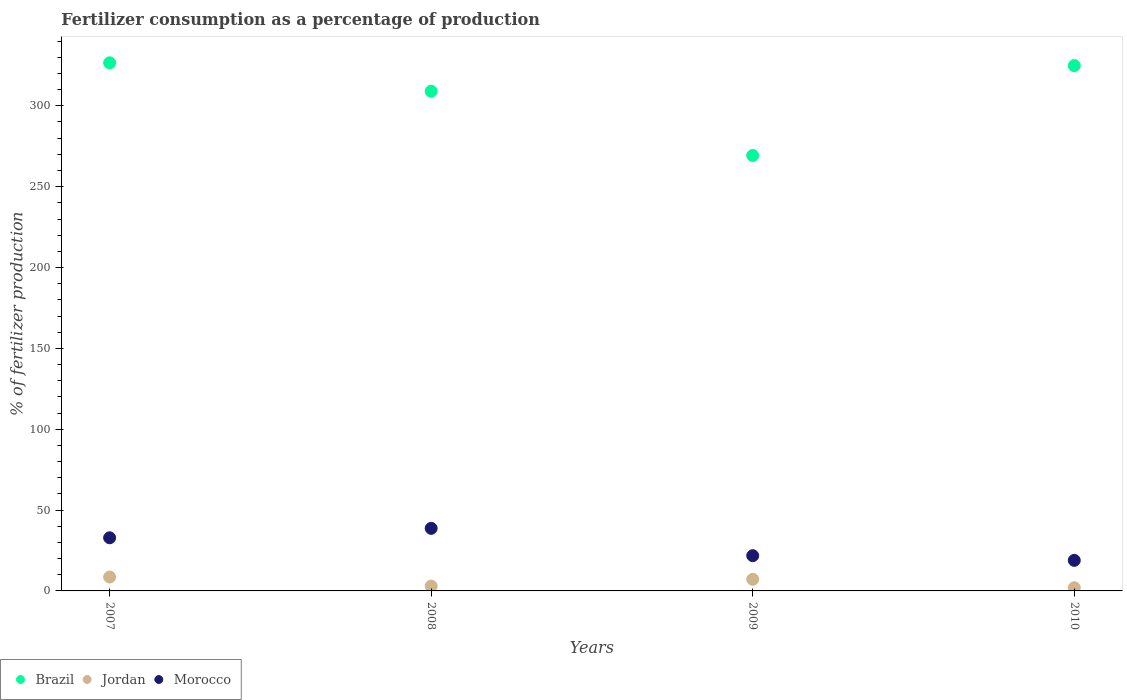What is the percentage of fertilizers consumed in Jordan in 2009?
Offer a very short reply. 7.18. Across all years, what is the maximum percentage of fertilizers consumed in Jordan?
Offer a very short reply. 8.6. Across all years, what is the minimum percentage of fertilizers consumed in Jordan?
Offer a very short reply. 1.96. In which year was the percentage of fertilizers consumed in Morocco maximum?
Your answer should be very brief. 2008. What is the total percentage of fertilizers consumed in Morocco in the graph?
Your response must be concise. 112.24. What is the difference between the percentage of fertilizers consumed in Brazil in 2007 and that in 2010?
Your answer should be very brief. 1.72. What is the difference between the percentage of fertilizers consumed in Brazil in 2007 and the percentage of fertilizers consumed in Morocco in 2009?
Keep it short and to the point. 304.79. What is the average percentage of fertilizers consumed in Brazil per year?
Provide a short and direct response. 307.43. In the year 2009, what is the difference between the percentage of fertilizers consumed in Brazil and percentage of fertilizers consumed in Jordan?
Ensure brevity in your answer.  262.09. In how many years, is the percentage of fertilizers consumed in Jordan greater than 310 %?
Give a very brief answer. 0. What is the ratio of the percentage of fertilizers consumed in Morocco in 2007 to that in 2009?
Give a very brief answer. 1.51. Is the percentage of fertilizers consumed in Morocco in 2007 less than that in 2009?
Keep it short and to the point. No. Is the difference between the percentage of fertilizers consumed in Brazil in 2007 and 2008 greater than the difference between the percentage of fertilizers consumed in Jordan in 2007 and 2008?
Your answer should be compact. Yes. What is the difference between the highest and the second highest percentage of fertilizers consumed in Brazil?
Give a very brief answer. 1.72. What is the difference between the highest and the lowest percentage of fertilizers consumed in Brazil?
Offer a terse response. 57.32. In how many years, is the percentage of fertilizers consumed in Brazil greater than the average percentage of fertilizers consumed in Brazil taken over all years?
Offer a very short reply. 3. Is the sum of the percentage of fertilizers consumed in Jordan in 2008 and 2010 greater than the maximum percentage of fertilizers consumed in Morocco across all years?
Offer a very short reply. No. Is it the case that in every year, the sum of the percentage of fertilizers consumed in Morocco and percentage of fertilizers consumed in Jordan  is greater than the percentage of fertilizers consumed in Brazil?
Make the answer very short. No. Does the percentage of fertilizers consumed in Morocco monotonically increase over the years?
Give a very brief answer. No. Is the percentage of fertilizers consumed in Morocco strictly greater than the percentage of fertilizers consumed in Brazil over the years?
Keep it short and to the point. No. Is the percentage of fertilizers consumed in Brazil strictly less than the percentage of fertilizers consumed in Jordan over the years?
Give a very brief answer. No. Does the graph contain any zero values?
Your answer should be very brief. No. Where does the legend appear in the graph?
Give a very brief answer. Bottom left. How are the legend labels stacked?
Your answer should be very brief. Horizontal. What is the title of the graph?
Make the answer very short. Fertilizer consumption as a percentage of production. Does "Mauritania" appear as one of the legend labels in the graph?
Provide a succinct answer. No. What is the label or title of the X-axis?
Keep it short and to the point. Years. What is the label or title of the Y-axis?
Give a very brief answer. % of fertilizer production. What is the % of fertilizer production in Brazil in 2007?
Ensure brevity in your answer.  326.59. What is the % of fertilizer production in Jordan in 2007?
Provide a short and direct response. 8.6. What is the % of fertilizer production in Morocco in 2007?
Offer a terse response. 32.86. What is the % of fertilizer production in Brazil in 2008?
Make the answer very short. 309.01. What is the % of fertilizer production of Jordan in 2008?
Your response must be concise. 2.99. What is the % of fertilizer production of Morocco in 2008?
Your answer should be compact. 38.69. What is the % of fertilizer production in Brazil in 2009?
Make the answer very short. 269.27. What is the % of fertilizer production of Jordan in 2009?
Your response must be concise. 7.18. What is the % of fertilizer production in Morocco in 2009?
Give a very brief answer. 21.79. What is the % of fertilizer production in Brazil in 2010?
Provide a short and direct response. 324.87. What is the % of fertilizer production in Jordan in 2010?
Make the answer very short. 1.96. What is the % of fertilizer production of Morocco in 2010?
Offer a terse response. 18.9. Across all years, what is the maximum % of fertilizer production of Brazil?
Keep it short and to the point. 326.59. Across all years, what is the maximum % of fertilizer production of Jordan?
Offer a terse response. 8.6. Across all years, what is the maximum % of fertilizer production of Morocco?
Your answer should be compact. 38.69. Across all years, what is the minimum % of fertilizer production in Brazil?
Provide a short and direct response. 269.27. Across all years, what is the minimum % of fertilizer production of Jordan?
Provide a succinct answer. 1.96. Across all years, what is the minimum % of fertilizer production of Morocco?
Provide a short and direct response. 18.9. What is the total % of fertilizer production in Brazil in the graph?
Ensure brevity in your answer.  1229.73. What is the total % of fertilizer production of Jordan in the graph?
Provide a short and direct response. 20.73. What is the total % of fertilizer production in Morocco in the graph?
Provide a short and direct response. 112.24. What is the difference between the % of fertilizer production in Brazil in 2007 and that in 2008?
Offer a very short reply. 17.58. What is the difference between the % of fertilizer production of Jordan in 2007 and that in 2008?
Offer a terse response. 5.61. What is the difference between the % of fertilizer production in Morocco in 2007 and that in 2008?
Your response must be concise. -5.83. What is the difference between the % of fertilizer production of Brazil in 2007 and that in 2009?
Your answer should be compact. 57.32. What is the difference between the % of fertilizer production of Jordan in 2007 and that in 2009?
Make the answer very short. 1.42. What is the difference between the % of fertilizer production of Morocco in 2007 and that in 2009?
Your answer should be compact. 11.07. What is the difference between the % of fertilizer production in Brazil in 2007 and that in 2010?
Your answer should be compact. 1.72. What is the difference between the % of fertilizer production of Jordan in 2007 and that in 2010?
Keep it short and to the point. 6.65. What is the difference between the % of fertilizer production in Morocco in 2007 and that in 2010?
Keep it short and to the point. 13.96. What is the difference between the % of fertilizer production in Brazil in 2008 and that in 2009?
Keep it short and to the point. 39.74. What is the difference between the % of fertilizer production of Jordan in 2008 and that in 2009?
Offer a very short reply. -4.19. What is the difference between the % of fertilizer production of Morocco in 2008 and that in 2009?
Give a very brief answer. 16.9. What is the difference between the % of fertilizer production in Brazil in 2008 and that in 2010?
Make the answer very short. -15.86. What is the difference between the % of fertilizer production in Jordan in 2008 and that in 2010?
Provide a succinct answer. 1.04. What is the difference between the % of fertilizer production in Morocco in 2008 and that in 2010?
Provide a short and direct response. 19.8. What is the difference between the % of fertilizer production of Brazil in 2009 and that in 2010?
Offer a very short reply. -55.6. What is the difference between the % of fertilizer production of Jordan in 2009 and that in 2010?
Make the answer very short. 5.22. What is the difference between the % of fertilizer production in Morocco in 2009 and that in 2010?
Keep it short and to the point. 2.9. What is the difference between the % of fertilizer production of Brazil in 2007 and the % of fertilizer production of Jordan in 2008?
Provide a succinct answer. 323.59. What is the difference between the % of fertilizer production in Brazil in 2007 and the % of fertilizer production in Morocco in 2008?
Offer a terse response. 287.89. What is the difference between the % of fertilizer production of Jordan in 2007 and the % of fertilizer production of Morocco in 2008?
Provide a short and direct response. -30.09. What is the difference between the % of fertilizer production in Brazil in 2007 and the % of fertilizer production in Jordan in 2009?
Ensure brevity in your answer.  319.41. What is the difference between the % of fertilizer production in Brazil in 2007 and the % of fertilizer production in Morocco in 2009?
Offer a very short reply. 304.79. What is the difference between the % of fertilizer production in Jordan in 2007 and the % of fertilizer production in Morocco in 2009?
Offer a terse response. -13.19. What is the difference between the % of fertilizer production in Brazil in 2007 and the % of fertilizer production in Jordan in 2010?
Provide a succinct answer. 324.63. What is the difference between the % of fertilizer production of Brazil in 2007 and the % of fertilizer production of Morocco in 2010?
Your answer should be compact. 307.69. What is the difference between the % of fertilizer production in Jordan in 2007 and the % of fertilizer production in Morocco in 2010?
Your response must be concise. -10.29. What is the difference between the % of fertilizer production of Brazil in 2008 and the % of fertilizer production of Jordan in 2009?
Your response must be concise. 301.83. What is the difference between the % of fertilizer production in Brazil in 2008 and the % of fertilizer production in Morocco in 2009?
Offer a very short reply. 287.22. What is the difference between the % of fertilizer production of Jordan in 2008 and the % of fertilizer production of Morocco in 2009?
Offer a terse response. -18.8. What is the difference between the % of fertilizer production in Brazil in 2008 and the % of fertilizer production in Jordan in 2010?
Your response must be concise. 307.05. What is the difference between the % of fertilizer production in Brazil in 2008 and the % of fertilizer production in Morocco in 2010?
Your answer should be very brief. 290.11. What is the difference between the % of fertilizer production in Jordan in 2008 and the % of fertilizer production in Morocco in 2010?
Make the answer very short. -15.9. What is the difference between the % of fertilizer production of Brazil in 2009 and the % of fertilizer production of Jordan in 2010?
Your response must be concise. 267.31. What is the difference between the % of fertilizer production in Brazil in 2009 and the % of fertilizer production in Morocco in 2010?
Offer a terse response. 250.37. What is the difference between the % of fertilizer production in Jordan in 2009 and the % of fertilizer production in Morocco in 2010?
Provide a succinct answer. -11.72. What is the average % of fertilizer production in Brazil per year?
Offer a terse response. 307.43. What is the average % of fertilizer production in Jordan per year?
Provide a short and direct response. 5.18. What is the average % of fertilizer production of Morocco per year?
Make the answer very short. 28.06. In the year 2007, what is the difference between the % of fertilizer production in Brazil and % of fertilizer production in Jordan?
Your answer should be compact. 317.98. In the year 2007, what is the difference between the % of fertilizer production in Brazil and % of fertilizer production in Morocco?
Provide a succinct answer. 293.73. In the year 2007, what is the difference between the % of fertilizer production in Jordan and % of fertilizer production in Morocco?
Offer a very short reply. -24.26. In the year 2008, what is the difference between the % of fertilizer production of Brazil and % of fertilizer production of Jordan?
Give a very brief answer. 306.02. In the year 2008, what is the difference between the % of fertilizer production in Brazil and % of fertilizer production in Morocco?
Your answer should be compact. 270.32. In the year 2008, what is the difference between the % of fertilizer production of Jordan and % of fertilizer production of Morocco?
Provide a short and direct response. -35.7. In the year 2009, what is the difference between the % of fertilizer production in Brazil and % of fertilizer production in Jordan?
Make the answer very short. 262.09. In the year 2009, what is the difference between the % of fertilizer production in Brazil and % of fertilizer production in Morocco?
Ensure brevity in your answer.  247.47. In the year 2009, what is the difference between the % of fertilizer production of Jordan and % of fertilizer production of Morocco?
Provide a succinct answer. -14.61. In the year 2010, what is the difference between the % of fertilizer production of Brazil and % of fertilizer production of Jordan?
Provide a short and direct response. 322.91. In the year 2010, what is the difference between the % of fertilizer production of Brazil and % of fertilizer production of Morocco?
Offer a very short reply. 305.97. In the year 2010, what is the difference between the % of fertilizer production of Jordan and % of fertilizer production of Morocco?
Give a very brief answer. -16.94. What is the ratio of the % of fertilizer production in Brazil in 2007 to that in 2008?
Provide a succinct answer. 1.06. What is the ratio of the % of fertilizer production in Jordan in 2007 to that in 2008?
Your response must be concise. 2.87. What is the ratio of the % of fertilizer production of Morocco in 2007 to that in 2008?
Offer a very short reply. 0.85. What is the ratio of the % of fertilizer production of Brazil in 2007 to that in 2009?
Your answer should be very brief. 1.21. What is the ratio of the % of fertilizer production of Jordan in 2007 to that in 2009?
Provide a short and direct response. 1.2. What is the ratio of the % of fertilizer production in Morocco in 2007 to that in 2009?
Offer a terse response. 1.51. What is the ratio of the % of fertilizer production in Brazil in 2007 to that in 2010?
Offer a terse response. 1.01. What is the ratio of the % of fertilizer production of Jordan in 2007 to that in 2010?
Your answer should be very brief. 4.39. What is the ratio of the % of fertilizer production of Morocco in 2007 to that in 2010?
Keep it short and to the point. 1.74. What is the ratio of the % of fertilizer production of Brazil in 2008 to that in 2009?
Keep it short and to the point. 1.15. What is the ratio of the % of fertilizer production of Jordan in 2008 to that in 2009?
Provide a short and direct response. 0.42. What is the ratio of the % of fertilizer production in Morocco in 2008 to that in 2009?
Offer a very short reply. 1.78. What is the ratio of the % of fertilizer production of Brazil in 2008 to that in 2010?
Your answer should be compact. 0.95. What is the ratio of the % of fertilizer production of Jordan in 2008 to that in 2010?
Provide a short and direct response. 1.53. What is the ratio of the % of fertilizer production of Morocco in 2008 to that in 2010?
Offer a very short reply. 2.05. What is the ratio of the % of fertilizer production of Brazil in 2009 to that in 2010?
Provide a short and direct response. 0.83. What is the ratio of the % of fertilizer production of Jordan in 2009 to that in 2010?
Your answer should be very brief. 3.67. What is the ratio of the % of fertilizer production in Morocco in 2009 to that in 2010?
Your answer should be compact. 1.15. What is the difference between the highest and the second highest % of fertilizer production in Brazil?
Keep it short and to the point. 1.72. What is the difference between the highest and the second highest % of fertilizer production of Jordan?
Offer a very short reply. 1.42. What is the difference between the highest and the second highest % of fertilizer production of Morocco?
Give a very brief answer. 5.83. What is the difference between the highest and the lowest % of fertilizer production in Brazil?
Provide a succinct answer. 57.32. What is the difference between the highest and the lowest % of fertilizer production of Jordan?
Offer a terse response. 6.65. What is the difference between the highest and the lowest % of fertilizer production in Morocco?
Your answer should be compact. 19.8. 